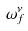<formula> <loc_0><loc_0><loc_500><loc_500>\omega _ { f } ^ { \nu }</formula> 